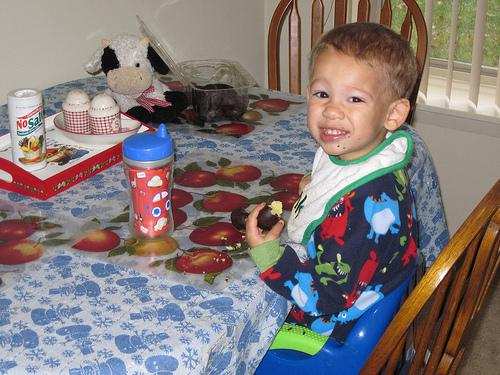Question: what color are the chairs?
Choices:
A. Black.
B. White.
C. Brown.
D. Green.
Answer with the letter. Answer: C Question: who is sitting in a chair?
Choices:
A. A woman.
B. A little girl.
C. A man.
D. The boy.
Answer with the letter. Answer: D Question: how many boys are there?
Choices:
A. Two.
B. Three.
C. Five.
D. One.
Answer with the letter. Answer: D Question: what are the chairs made of?
Choices:
A. Wood.
B. Metal.
C. Iron.
D. Cloth.
Answer with the letter. Answer: A 